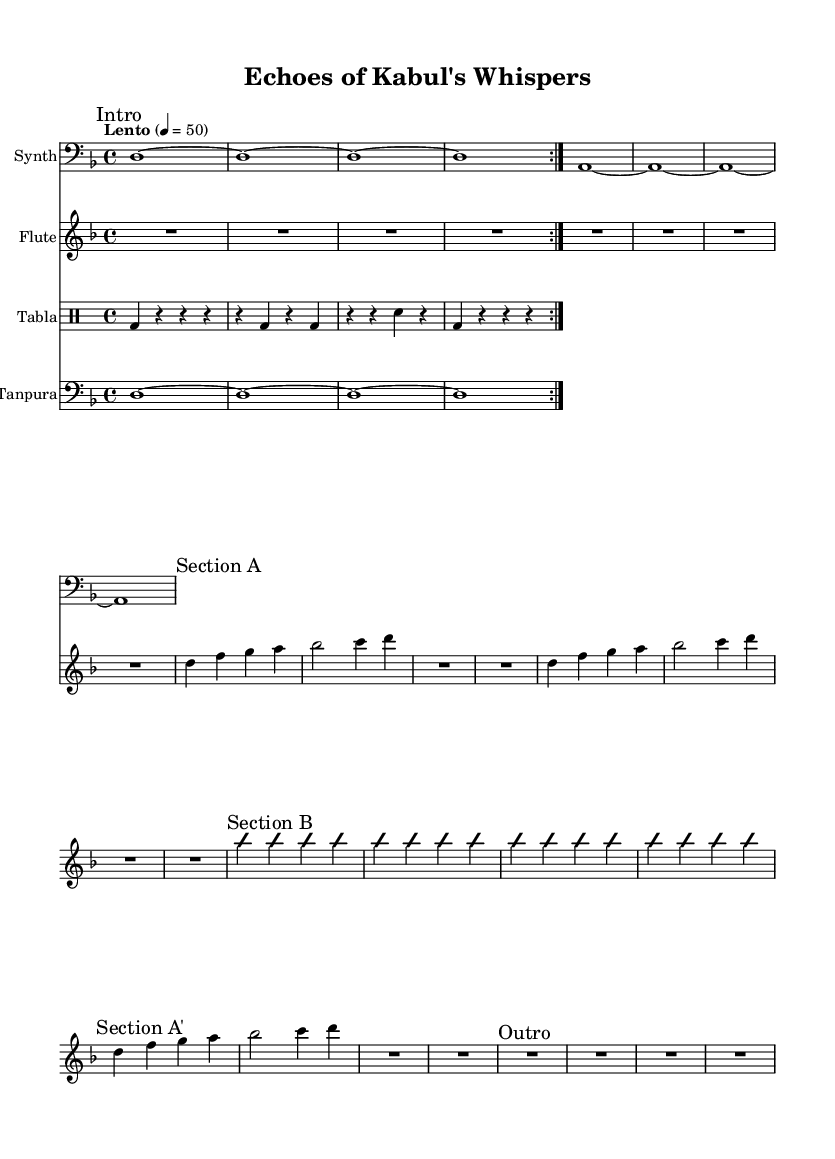What is the key signature of this music? The key signature is D minor, indicated by one flat (B flat) in the beginning of the score.
Answer: D minor What is the time signature of this piece? The time signature is four-four, specified at the beginning of the score with the notation "4/4."
Answer: 4/4 What is the tempo marking for this music? The tempo marking is "Lento," which suggests a slow pace, and is indicated with the notation "4 = 50."
Answer: Lento How many measures are in Section A? Section A consists of four measures as indicated by the musical notation provided, showing a sequence of notes without any interruptions.
Answer: 4 What does the "improvisationOn" mark signify in Section B? The "improvisationOn" mark indicates that the musician is to improvise starting from this point, allowing for spontaneous musical expression that differs from the written notes.
Answer: Improvisation What is the instrument initially notated in the score? The first instrument notated in the score is the Synth, listed at the beginning of the score.
Answer: Synth How many times is the bass drum (bd) played in the Tabla section's first volta? In the first volta of the Tabla section, the bass drum (bd) is played two times as denoted in the rhythm section.
Answer: 2 